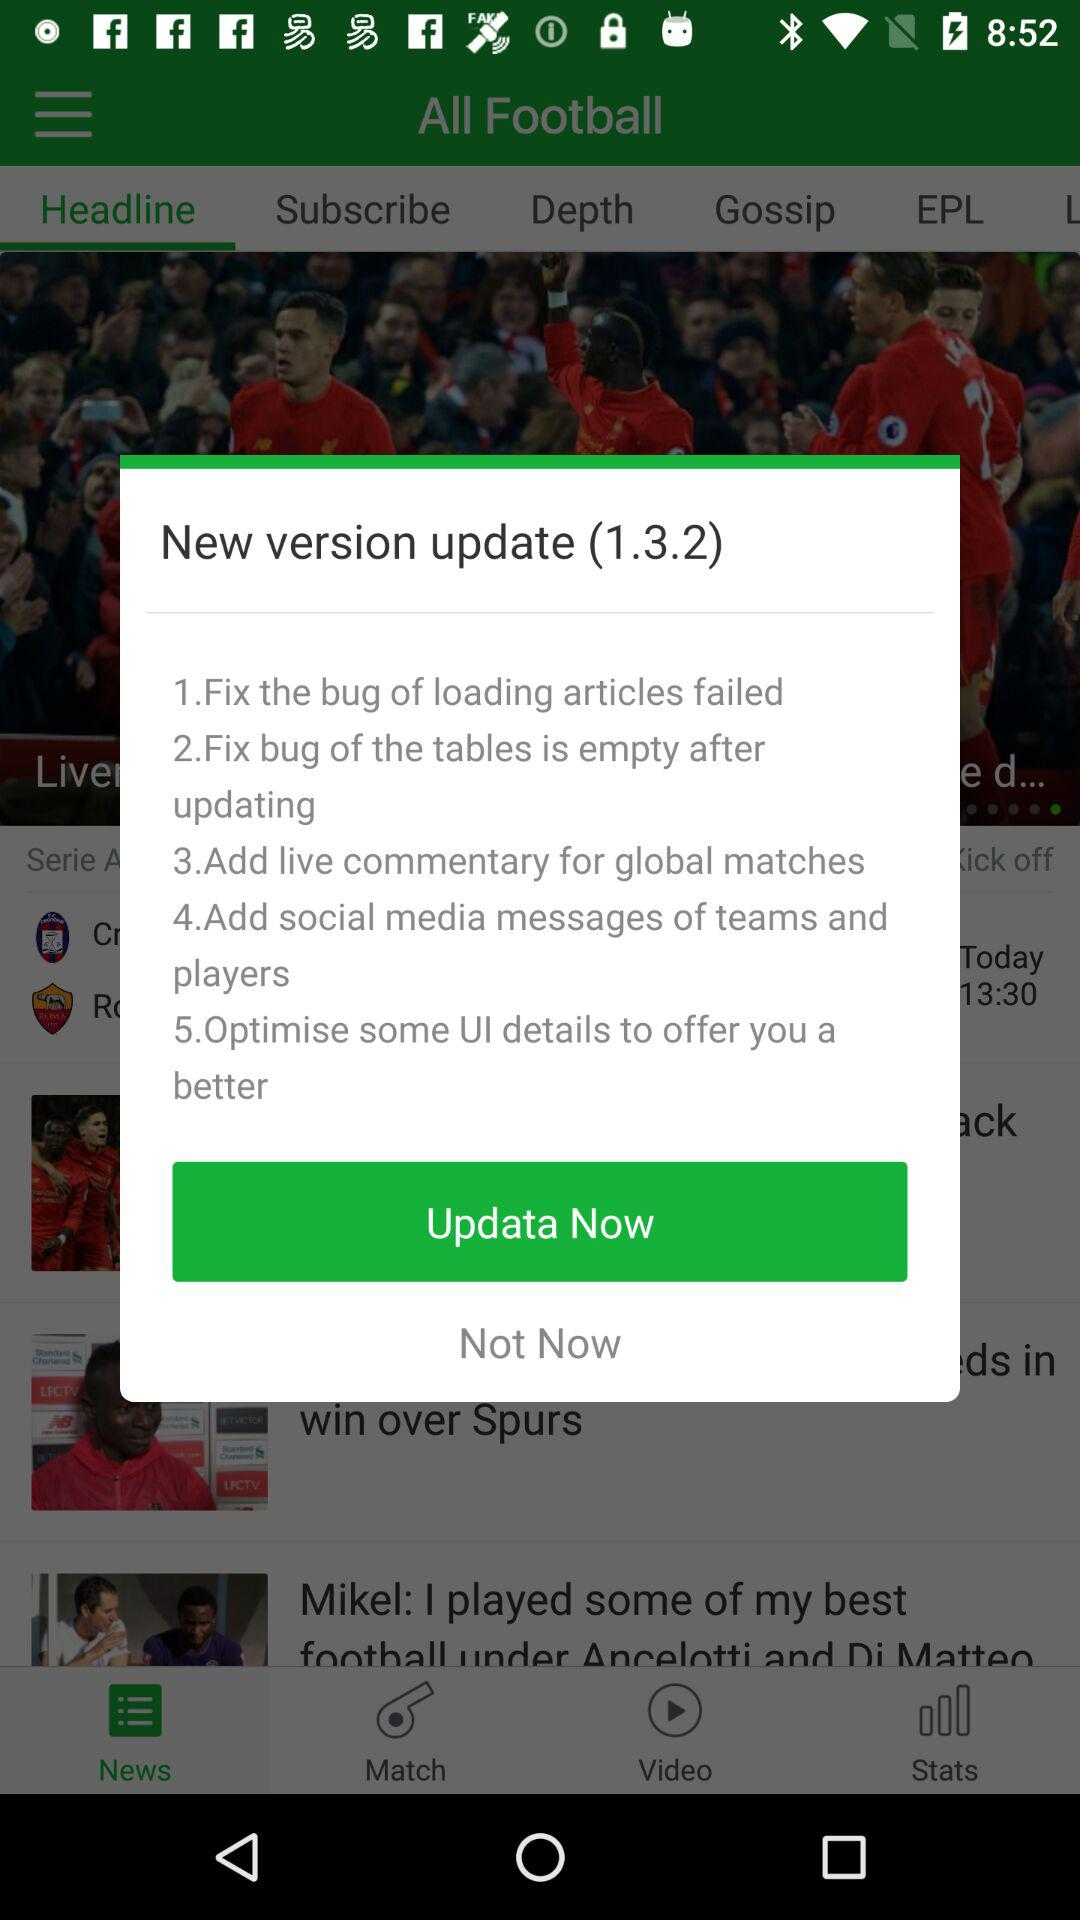What is the updated version? The updated version is 1.3.2. 